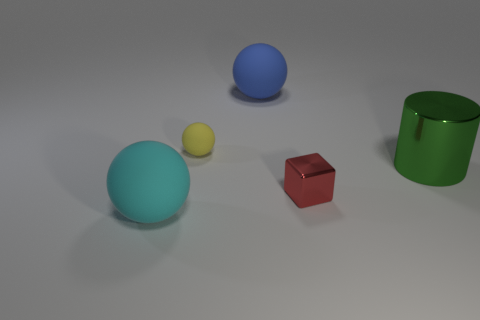There is a big rubber ball that is behind the rubber thing in front of the large green thing; what number of red objects are behind it?
Your response must be concise. 0. There is a tiny red shiny thing; are there any big rubber spheres behind it?
Your answer should be compact. Yes. The large blue rubber object is what shape?
Provide a short and direct response. Sphere. There is a tiny object that is right of the large sphere behind the tiny object that is in front of the shiny cylinder; what shape is it?
Make the answer very short. Cube. How many other things are the same shape as the large blue rubber thing?
Your answer should be compact. 2. What material is the big sphere that is in front of the large ball that is behind the big cyan matte thing made of?
Provide a short and direct response. Rubber. Is the big cyan ball made of the same material as the big object that is behind the cylinder?
Your answer should be compact. Yes. What is the material of the object that is to the left of the metal block and in front of the large green metal object?
Make the answer very short. Rubber. What is the color of the large object right of the large blue matte object on the left side of the metallic cube?
Your answer should be compact. Green. There is a thing to the left of the small yellow matte sphere; what is its material?
Give a very brief answer. Rubber. 